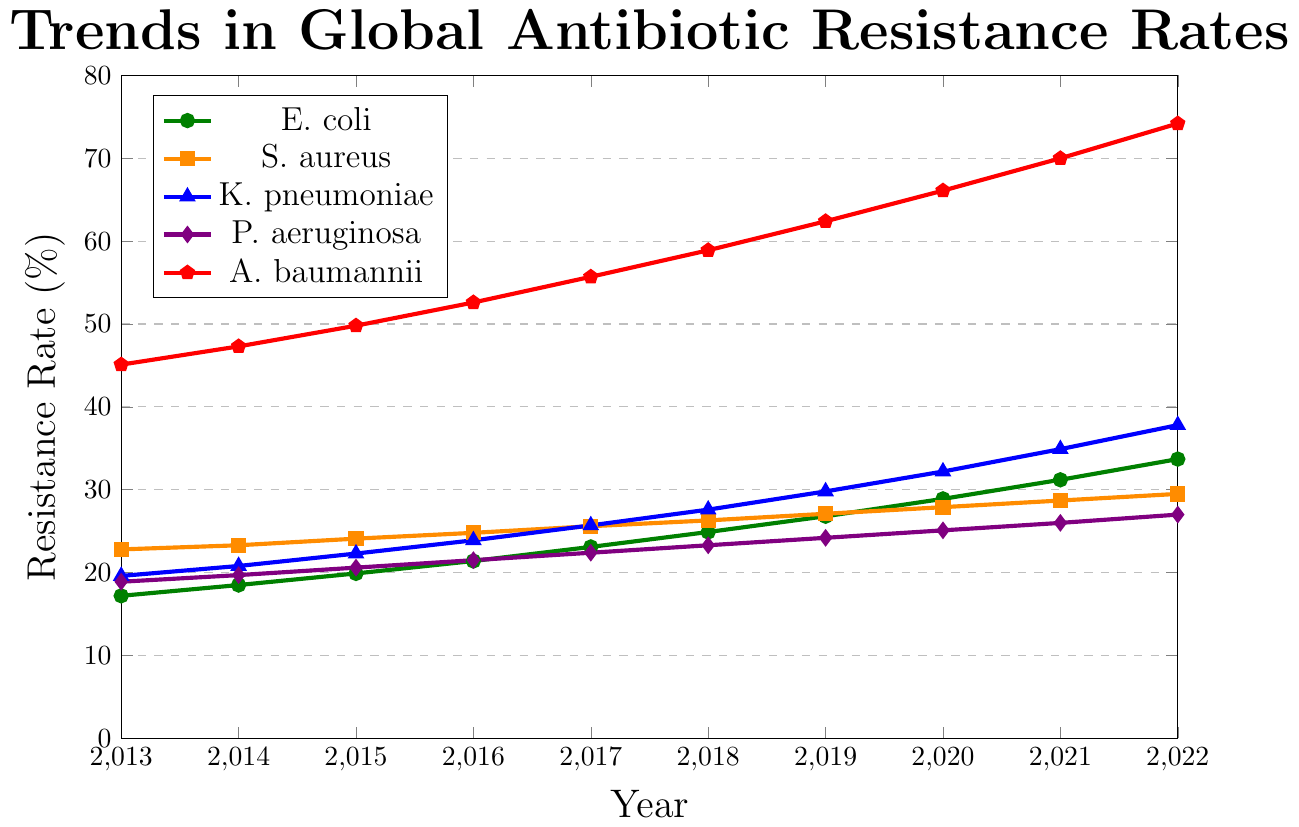What's the overall trend in antibiotic resistance rates for A. baumannii from 2013 to 2022? The line representing A. baumannii steadily increases from 45.1% in 2013 to 74.2% in 2022, indicating a continuous rise in resistance rates over the years.
Answer: Continuous rise Which pathogen shows the steepest increase in resistance rates over the past decade? By comparing the slopes of the lines, A. baumannii shows a significant increase from 45.1% in 2013 to 74.2% in 2022, which is the steepest among all pathogens.
Answer: A. baumannii In which year did S. aureus surpass a 25% resistance rate? Referring to the S. aureus line, it surpassed the 25% threshold in the year 2017.
Answer: 2017 How much did the resistance rate for E. coli increase from 2013 to 2022? The resistance rate for E. coli increased from 17.2% in 2013 to 33.7% in 2022. The difference is 33.7 - 17.2 = 16.5%.
Answer: 16.5% Compare the resistance rates of K. pneumoniae and P. aeruginosa in 2020. Which one was higher? In 2020, the resistance rate for K. pneumoniae was 32.2%, while for P. aeruginosa, it was 25.1%. Hence, K. pneumoniae had a higher resistance rate.
Answer: K. pneumoniae Which pathogen had the lowest resistance rate in 2013, and what was the value? By looking at the lines in 2013, E. coli had the lowest resistance rate at 17.2%.
Answer: E. coli, 17.2% Calculate the average resistance rate for S. aureus over the decade from 2013 to 2022. Summing the resistance rates for S. aureus from 2013 to 2022: (22.8 + 23.3 + 24.1 + 24.8 + 25.6 + 26.3 + 27.1 + 27.9 + 28.7 + 29.5) = 260.1. Dividing by 10 years gives an average of 260.1 / 10 = 26.01%.
Answer: 26.01% In what year do the resistance rates of P. aeruginosa exceed 20%? The line for P. aeruginosa crosses the 20% mark in the year 2015.
Answer: 2015 Between 2018 and 2020, which pathogen exhibited the largest increase in resistance rate? By comparing the increases between 2018 and 2020: E. coli (28.9 - 24.9 = 4.0), S. aureus (27.9 - 26.3 = 1.6), K. pneumoniae (32.2 - 27.6 = 4.6), P. aeruginosa (25.1 - 23.3 = 1.8), A. baumannii (66.1 - 58.9 = 7.2). A. baumannii exhibited the largest increase.
Answer: A. baumannii, 7.2% What is the trend for K. pneumoniae from 2013 to 2022 and which years did it show the most significant jumps? K. pneumoniae shows a general increasing trend from 19.6% in 2013 to 37.8% in 2022. The significant jumps in resistance are observed between 2018 to 2019 (27.6 to 29.8) and between 2019 to 2020 (29.8 to 32.2).
Answer: Increasing trend; major jumps: 2018-2019, 2019-2020 